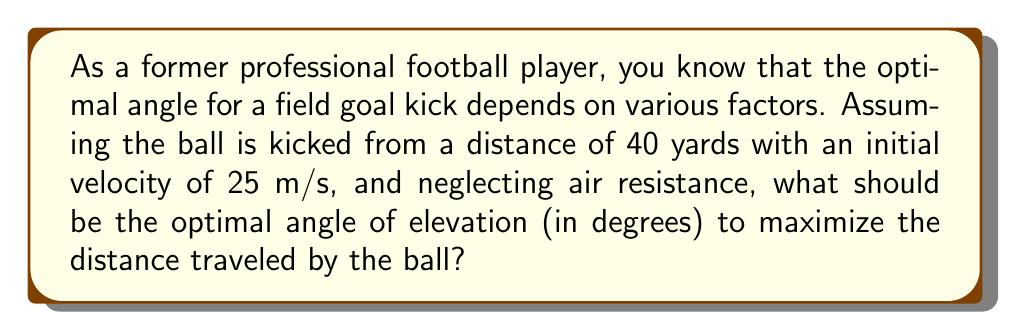Can you solve this math problem? Let's approach this step-by-step using projectile motion equations and trigonometry:

1) The range (R) of a projectile launched at an angle θ with initial velocity v is given by:

   $$R = \frac{v^2 \sin(2θ)}{g}$$

   where g is the acceleration due to gravity (9.8 m/s²).

2) To maximize R, we need to maximize $\sin(2θ)$. This occurs when $2θ = 90°$ or $θ = 45°$.

3) However, in football, we need to consider that the goal posts are elevated. The crossbar height is 10 feet (3.05 meters).

4) Let's convert 40 yards to meters: 40 yards = 36.576 meters

5) Now, we need to solve for θ in the equation:

   $$3.05 = 36.576 \tan(θ) - \frac{9.8 \cdot 36.576^2}{2 \cdot 25^2 \cos^2(θ)}$$

6) This equation can be solved numerically, resulting in θ ≈ 43.8°

Therefore, the optimal angle for the kick is slightly less than 45° due to the elevation of the goal posts.
Answer: $43.8°$ 